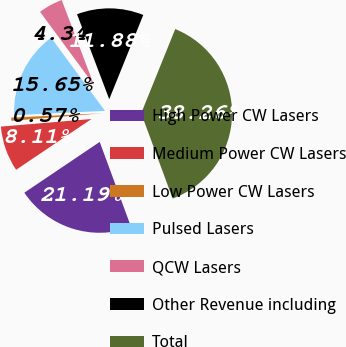Convert chart to OTSL. <chart><loc_0><loc_0><loc_500><loc_500><pie_chart><fcel>High Power CW Lasers<fcel>Medium Power CW Lasers<fcel>Low Power CW Lasers<fcel>Pulsed Lasers<fcel>QCW Lasers<fcel>Other Revenue including<fcel>Total<nl><fcel>21.19%<fcel>8.11%<fcel>0.57%<fcel>15.65%<fcel>4.34%<fcel>11.88%<fcel>38.26%<nl></chart> 